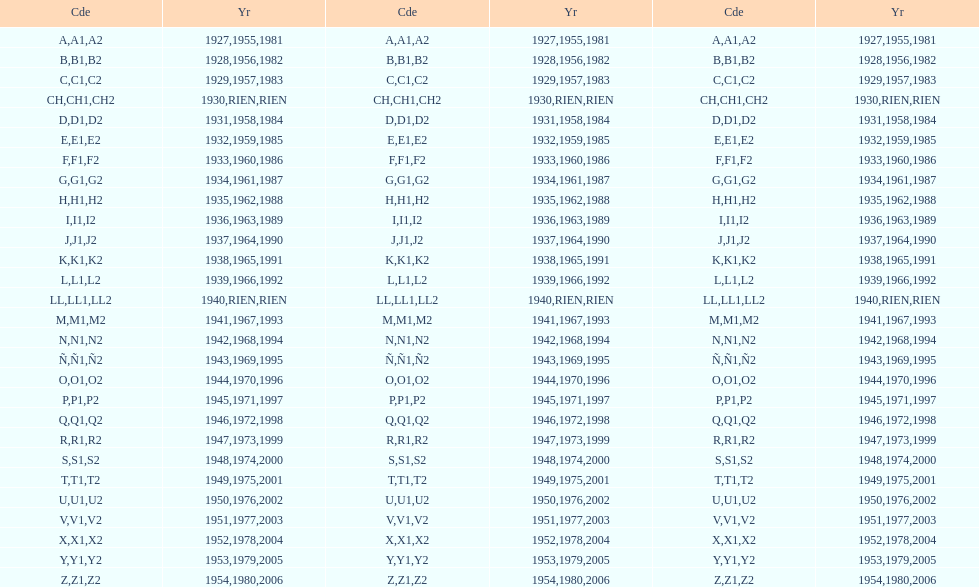How many different codes were used from 1953 to 1958? 6. 